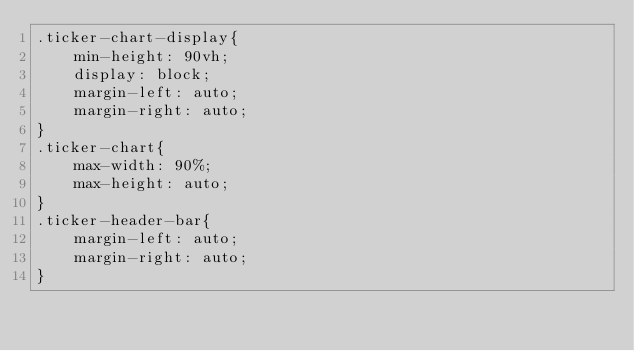<code> <loc_0><loc_0><loc_500><loc_500><_CSS_>.ticker-chart-display{
    min-height: 90vh;
    display: block;
    margin-left: auto;
    margin-right: auto;
}
.ticker-chart{
    max-width: 90%;
    max-height: auto;
}
.ticker-header-bar{
    margin-left: auto;
    margin-right: auto;
}
</code> 